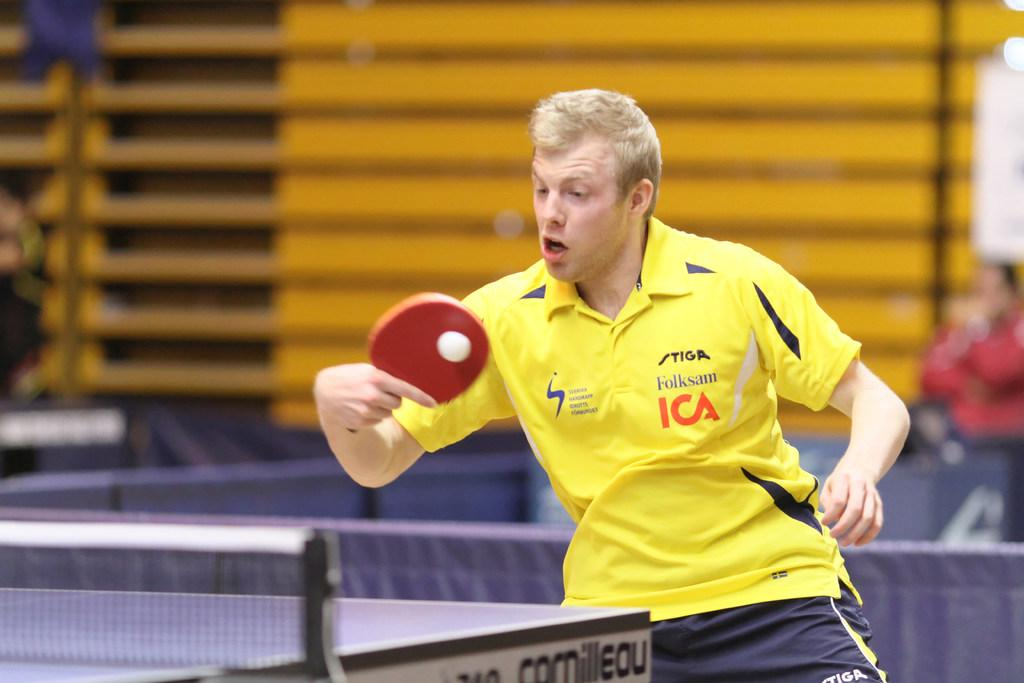<image>
Give a short and clear explanation of the subsequent image. The ICA sponsored table tennis player strikes the ball. 